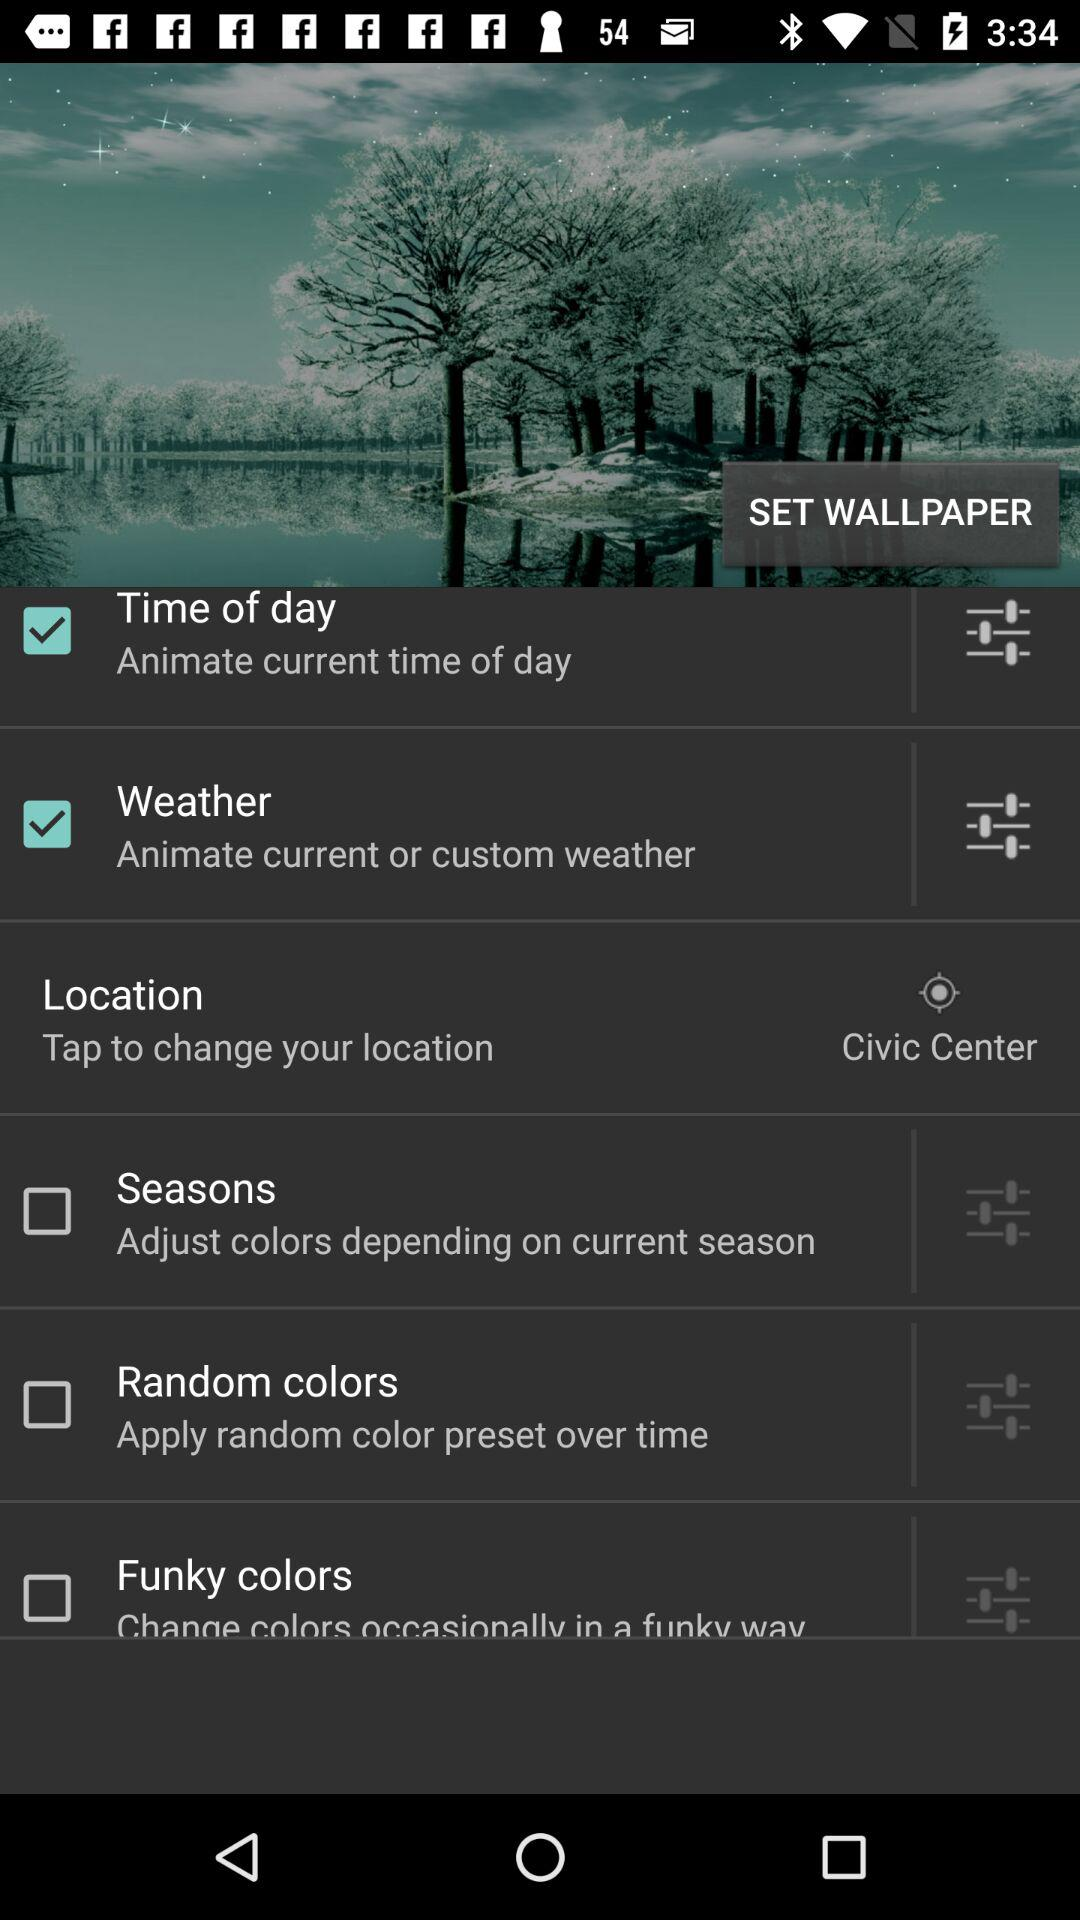What is the status of custom weather? The status is "on". 